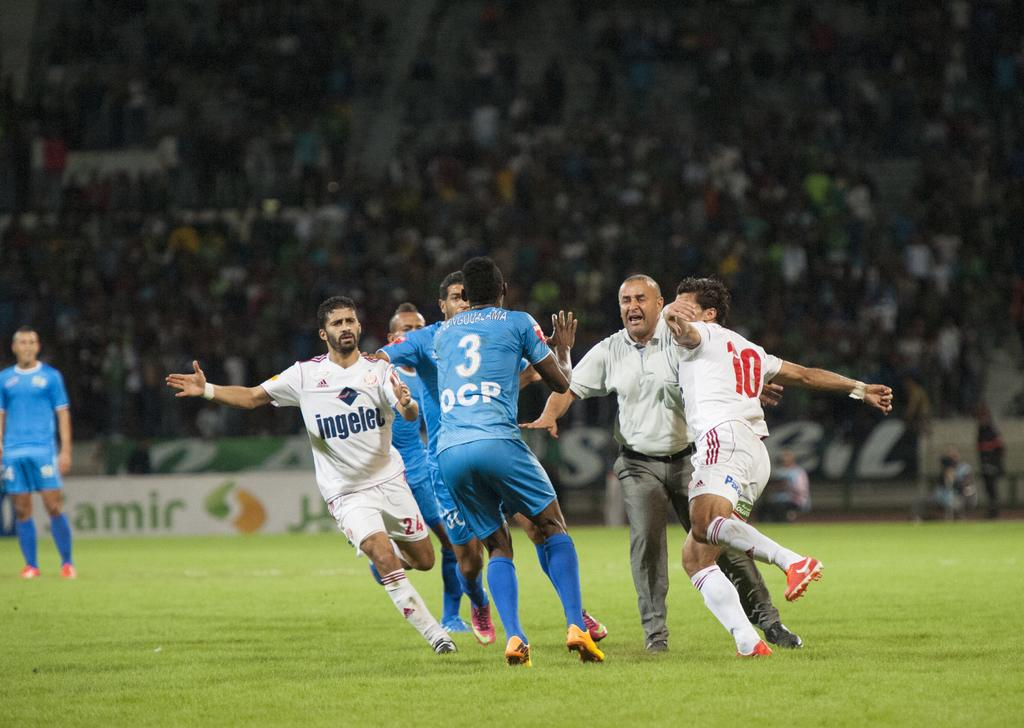<image>
Describe the image concisely. A group of soccer players are scrambling in the field by a referee and one of their shirts says Ingelez. 